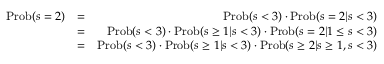<formula> <loc_0><loc_0><loc_500><loc_500>\begin{array} { r l r } { P r o b ( s = 2 ) } & { = } & { P r o b ( s < 3 ) \cdot P r o b ( s = 2 | s < 3 ) } \\ & { = } & { P r o b ( s < 3 ) \cdot P r o b ( s \geq 1 | s < 3 ) \cdot P r o b ( s = 2 | 1 \leq s < 3 ) } \\ & { = } & { P r o b ( s < 3 ) \cdot P r o b ( s \geq 1 | s < 3 ) \cdot P r o b ( s \geq 2 | s \geq 1 , s < 3 ) } \end{array}</formula> 